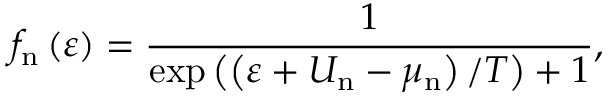<formula> <loc_0><loc_0><loc_500><loc_500>f _ { n } \left ( \varepsilon \right ) = \frac { 1 } { \exp \left ( \left ( \varepsilon + U _ { n } - \mu _ { n } \right ) / T \right ) + 1 } ,</formula> 